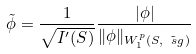Convert formula to latex. <formula><loc_0><loc_0><loc_500><loc_500>\tilde { \phi } = \frac { 1 } { \sqrt { I ^ { \prime } ( S ) } } \frac { | \phi | } { \| \phi \| _ { W _ { 1 } ^ { p } ( S , \tilde { \ s g } ) } }</formula> 